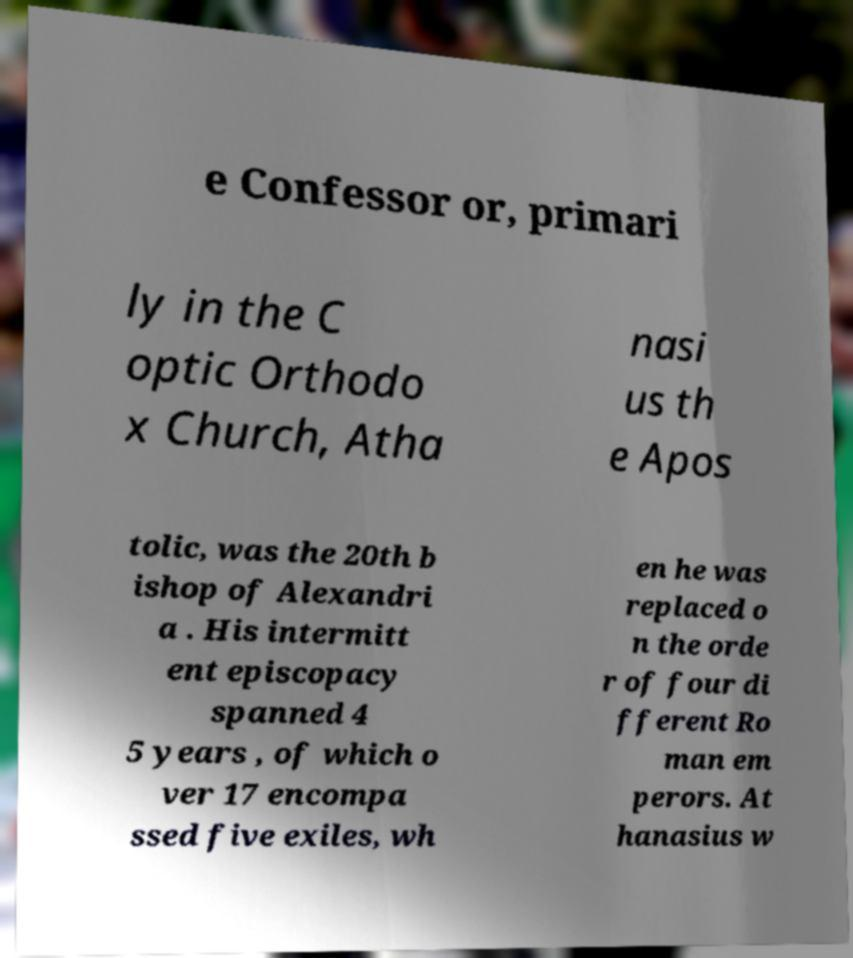What messages or text are displayed in this image? I need them in a readable, typed format. e Confessor or, primari ly in the C optic Orthodo x Church, Atha nasi us th e Apos tolic, was the 20th b ishop of Alexandri a . His intermitt ent episcopacy spanned 4 5 years , of which o ver 17 encompa ssed five exiles, wh en he was replaced o n the orde r of four di fferent Ro man em perors. At hanasius w 